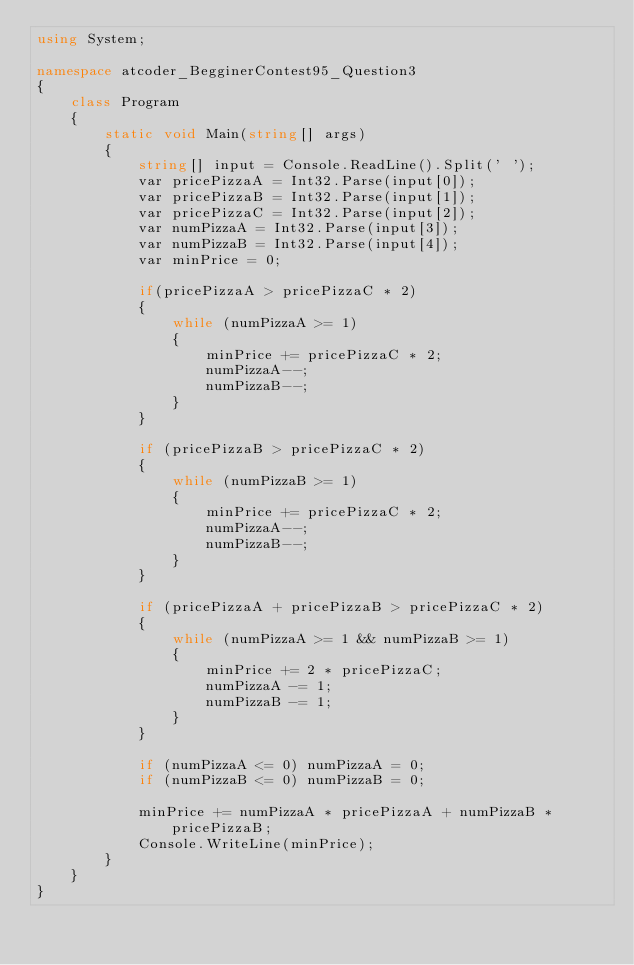<code> <loc_0><loc_0><loc_500><loc_500><_C#_>using System;

namespace atcoder_BegginerContest95_Question3
{
    class Program
    {
        static void Main(string[] args)
        {
            string[] input = Console.ReadLine().Split(' ');
            var pricePizzaA = Int32.Parse(input[0]);
            var pricePizzaB = Int32.Parse(input[1]);
            var pricePizzaC = Int32.Parse(input[2]);
            var numPizzaA = Int32.Parse(input[3]);
            var numPizzaB = Int32.Parse(input[4]);
            var minPrice = 0;

            if(pricePizzaA > pricePizzaC * 2)
            {
                while (numPizzaA >= 1)
                {
                    minPrice += pricePizzaC * 2;
                    numPizzaA--;
                    numPizzaB--;
                }
            }

            if (pricePizzaB > pricePizzaC * 2)
            {
                while (numPizzaB >= 1)
                {
                    minPrice += pricePizzaC * 2;
                    numPizzaA--;
                    numPizzaB--;
                }
            }

            if (pricePizzaA + pricePizzaB > pricePizzaC * 2)
            {
                while (numPizzaA >= 1 && numPizzaB >= 1)
                {
                    minPrice += 2 * pricePizzaC;
                    numPizzaA -= 1;
                    numPizzaB -= 1;
                }
            }

            if (numPizzaA <= 0) numPizzaA = 0;
            if (numPizzaB <= 0) numPizzaB = 0;

            minPrice += numPizzaA * pricePizzaA + numPizzaB * pricePizzaB;
            Console.WriteLine(minPrice);
        }
    }
}
</code> 